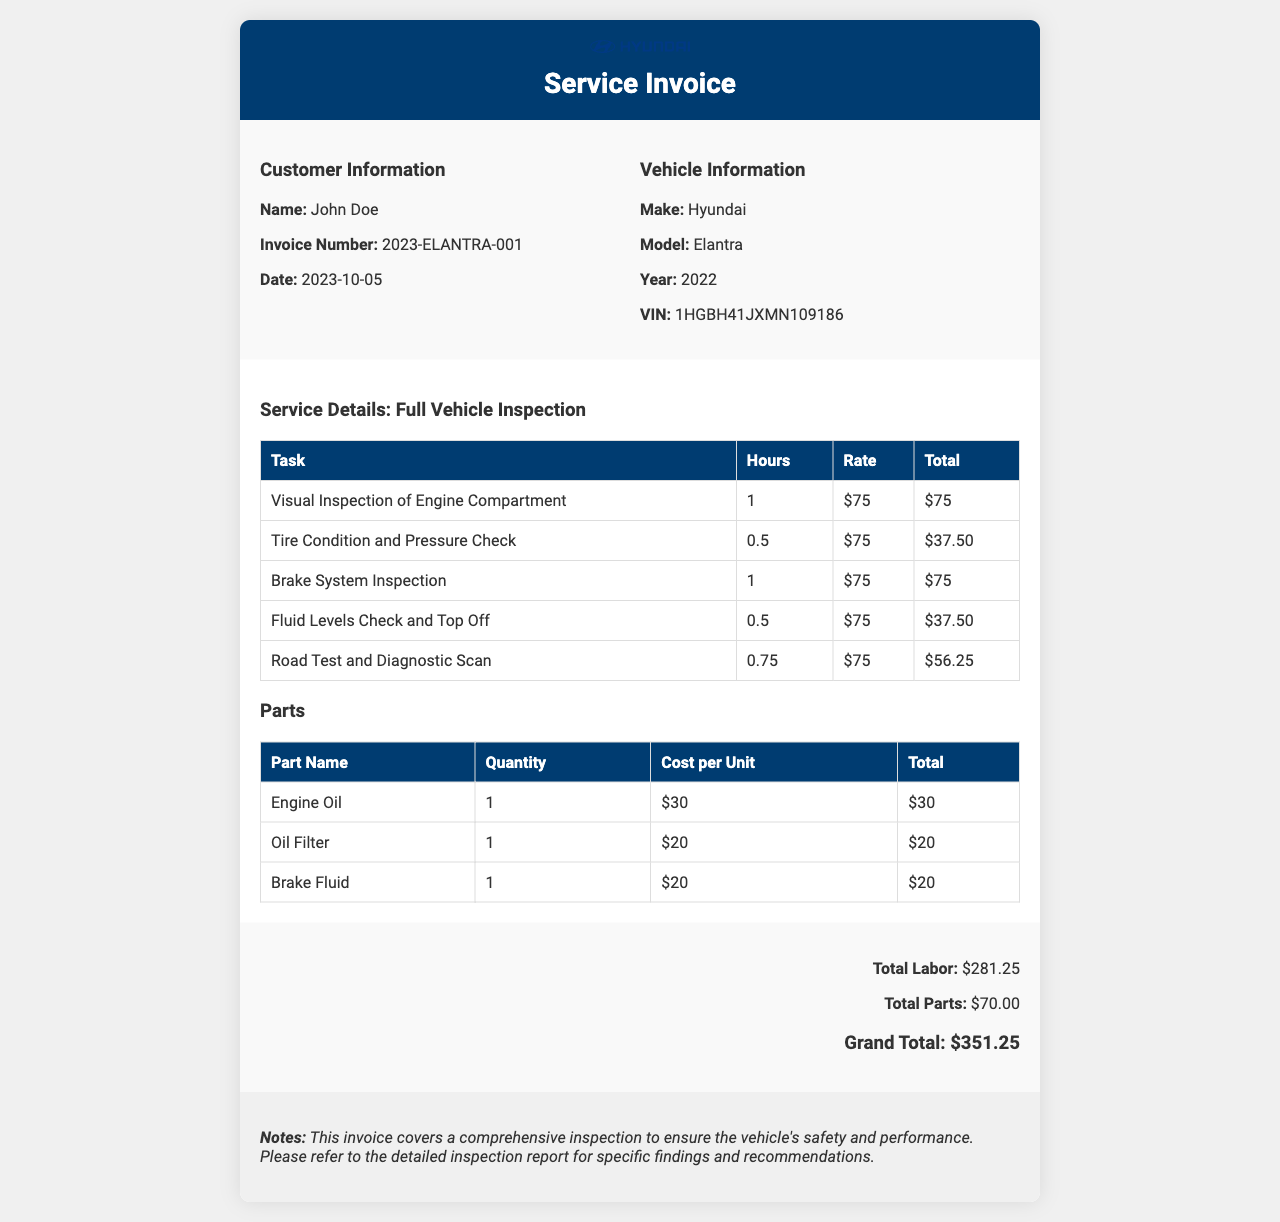what is the customer's name? The customer's name is displayed in the customer information section of the invoice.
Answer: John Doe what is the invoice number? The invoice number is listed under the customer information section, indicated for reference.
Answer: 2023-ELANTRA-001 what date was the service performed? The date of the service is recorded in the invoice, showing when the inspection occurred.
Answer: 2023-10-05 how much was charged for labor in total? The total labor cost is summarized at the end of the invoice, representing the sum of all labor tasks performed.
Answer: $281.25 how many parts were listed in the invoice? The invoice details show the number of distinct parts as listed under the parts section.
Answer: 3 what is the total amount for parts? The total cost for parts is stated in the summary section, providing a direct figure for parts expenses.
Answer: $70.00 what is the grand total for the service? The grand total is calculated as the sum of total labor and total parts, found in the summary section.
Answer: $351.25 what type of inspection is noted in the document? The document specifies the type of service performed, indicating the nature of the inspection carried out on the vehicle.
Answer: Full Vehicle Inspection what does the notes section indicate about the inspection? The notes section provides insights into the purpose of the inspection and encourages referring to a detailed report for further information.
Answer: Comprehensive inspection for safety and performance 